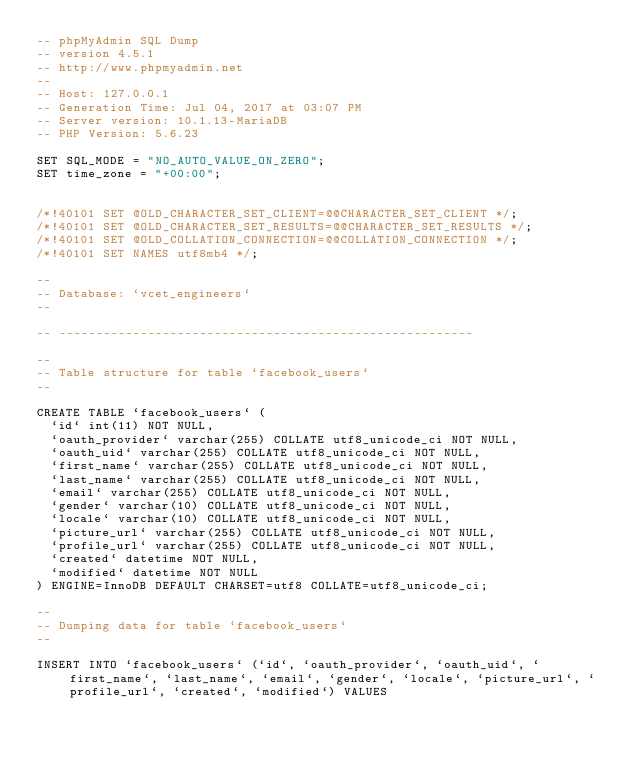Convert code to text. <code><loc_0><loc_0><loc_500><loc_500><_SQL_>-- phpMyAdmin SQL Dump
-- version 4.5.1
-- http://www.phpmyadmin.net
--
-- Host: 127.0.0.1
-- Generation Time: Jul 04, 2017 at 03:07 PM
-- Server version: 10.1.13-MariaDB
-- PHP Version: 5.6.23

SET SQL_MODE = "NO_AUTO_VALUE_ON_ZERO";
SET time_zone = "+00:00";


/*!40101 SET @OLD_CHARACTER_SET_CLIENT=@@CHARACTER_SET_CLIENT */;
/*!40101 SET @OLD_CHARACTER_SET_RESULTS=@@CHARACTER_SET_RESULTS */;
/*!40101 SET @OLD_COLLATION_CONNECTION=@@COLLATION_CONNECTION */;
/*!40101 SET NAMES utf8mb4 */;

--
-- Database: `vcet_engineers`
--

-- --------------------------------------------------------

--
-- Table structure for table `facebook_users`
--

CREATE TABLE `facebook_users` (
  `id` int(11) NOT NULL,
  `oauth_provider` varchar(255) COLLATE utf8_unicode_ci NOT NULL,
  `oauth_uid` varchar(255) COLLATE utf8_unicode_ci NOT NULL,
  `first_name` varchar(255) COLLATE utf8_unicode_ci NOT NULL,
  `last_name` varchar(255) COLLATE utf8_unicode_ci NOT NULL,
  `email` varchar(255) COLLATE utf8_unicode_ci NOT NULL,
  `gender` varchar(10) COLLATE utf8_unicode_ci NOT NULL,
  `locale` varchar(10) COLLATE utf8_unicode_ci NOT NULL,
  `picture_url` varchar(255) COLLATE utf8_unicode_ci NOT NULL,
  `profile_url` varchar(255) COLLATE utf8_unicode_ci NOT NULL,
  `created` datetime NOT NULL,
  `modified` datetime NOT NULL
) ENGINE=InnoDB DEFAULT CHARSET=utf8 COLLATE=utf8_unicode_ci;

--
-- Dumping data for table `facebook_users`
--

INSERT INTO `facebook_users` (`id`, `oauth_provider`, `oauth_uid`, `first_name`, `last_name`, `email`, `gender`, `locale`, `picture_url`, `profile_url`, `created`, `modified`) VALUES</code> 